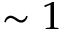<formula> <loc_0><loc_0><loc_500><loc_500>\sim 1</formula> 